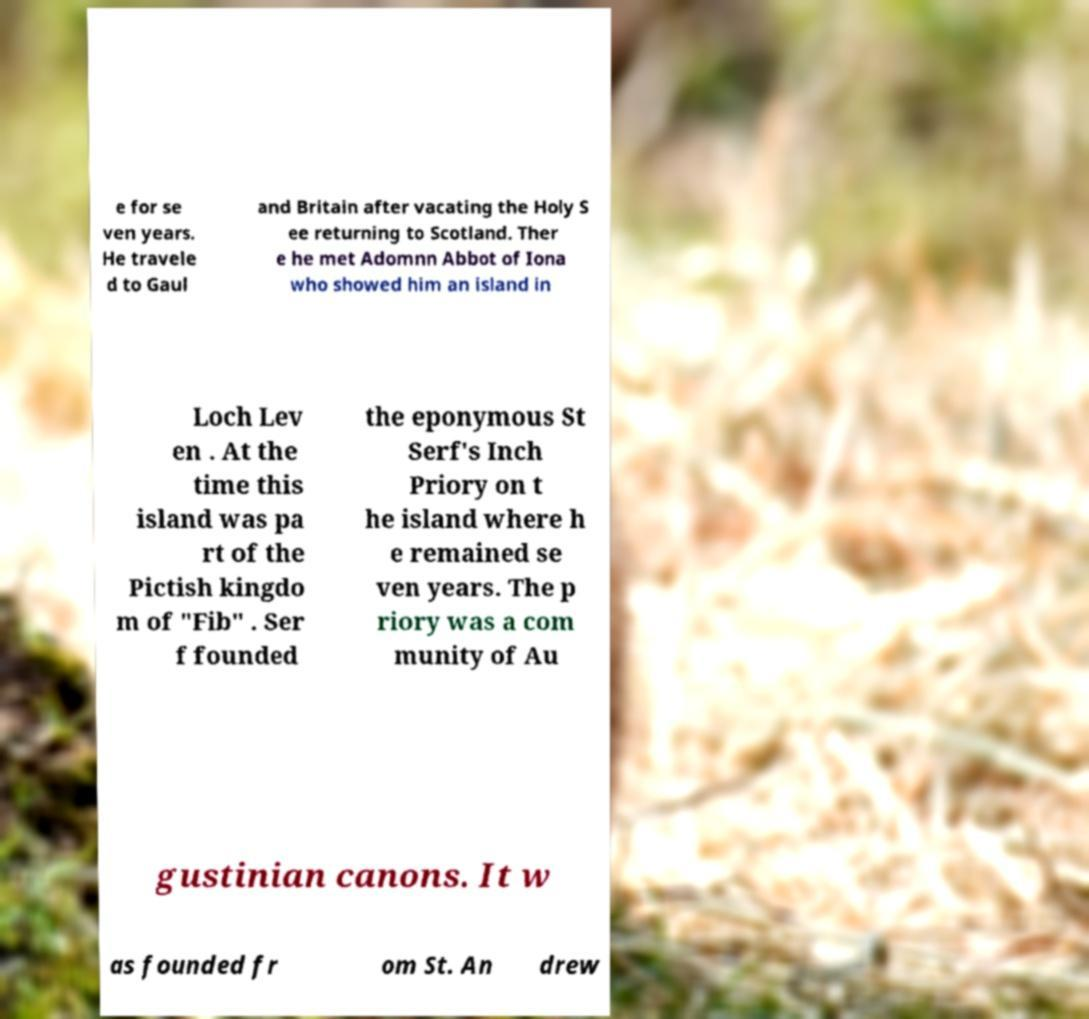Could you extract and type out the text from this image? e for se ven years. He travele d to Gaul and Britain after vacating the Holy S ee returning to Scotland. Ther e he met Adomnn Abbot of Iona who showed him an island in Loch Lev en . At the time this island was pa rt of the Pictish kingdo m of "Fib" . Ser f founded the eponymous St Serf's Inch Priory on t he island where h e remained se ven years. The p riory was a com munity of Au gustinian canons. It w as founded fr om St. An drew 